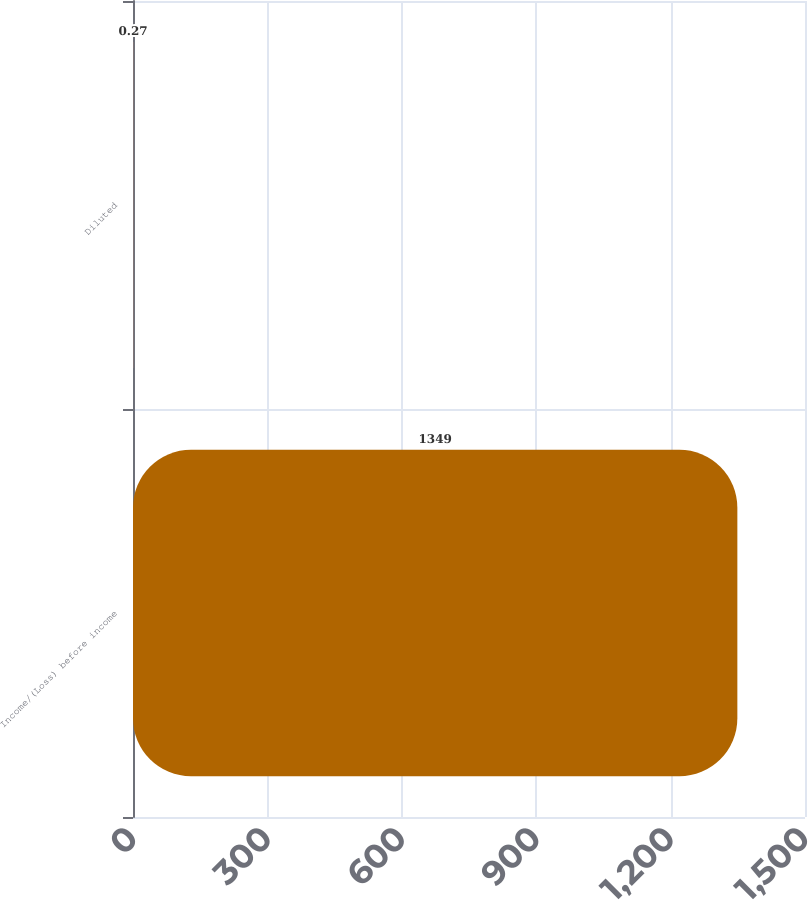<chart> <loc_0><loc_0><loc_500><loc_500><bar_chart><fcel>Income/(Loss) before income<fcel>Diluted<nl><fcel>1349<fcel>0.27<nl></chart> 